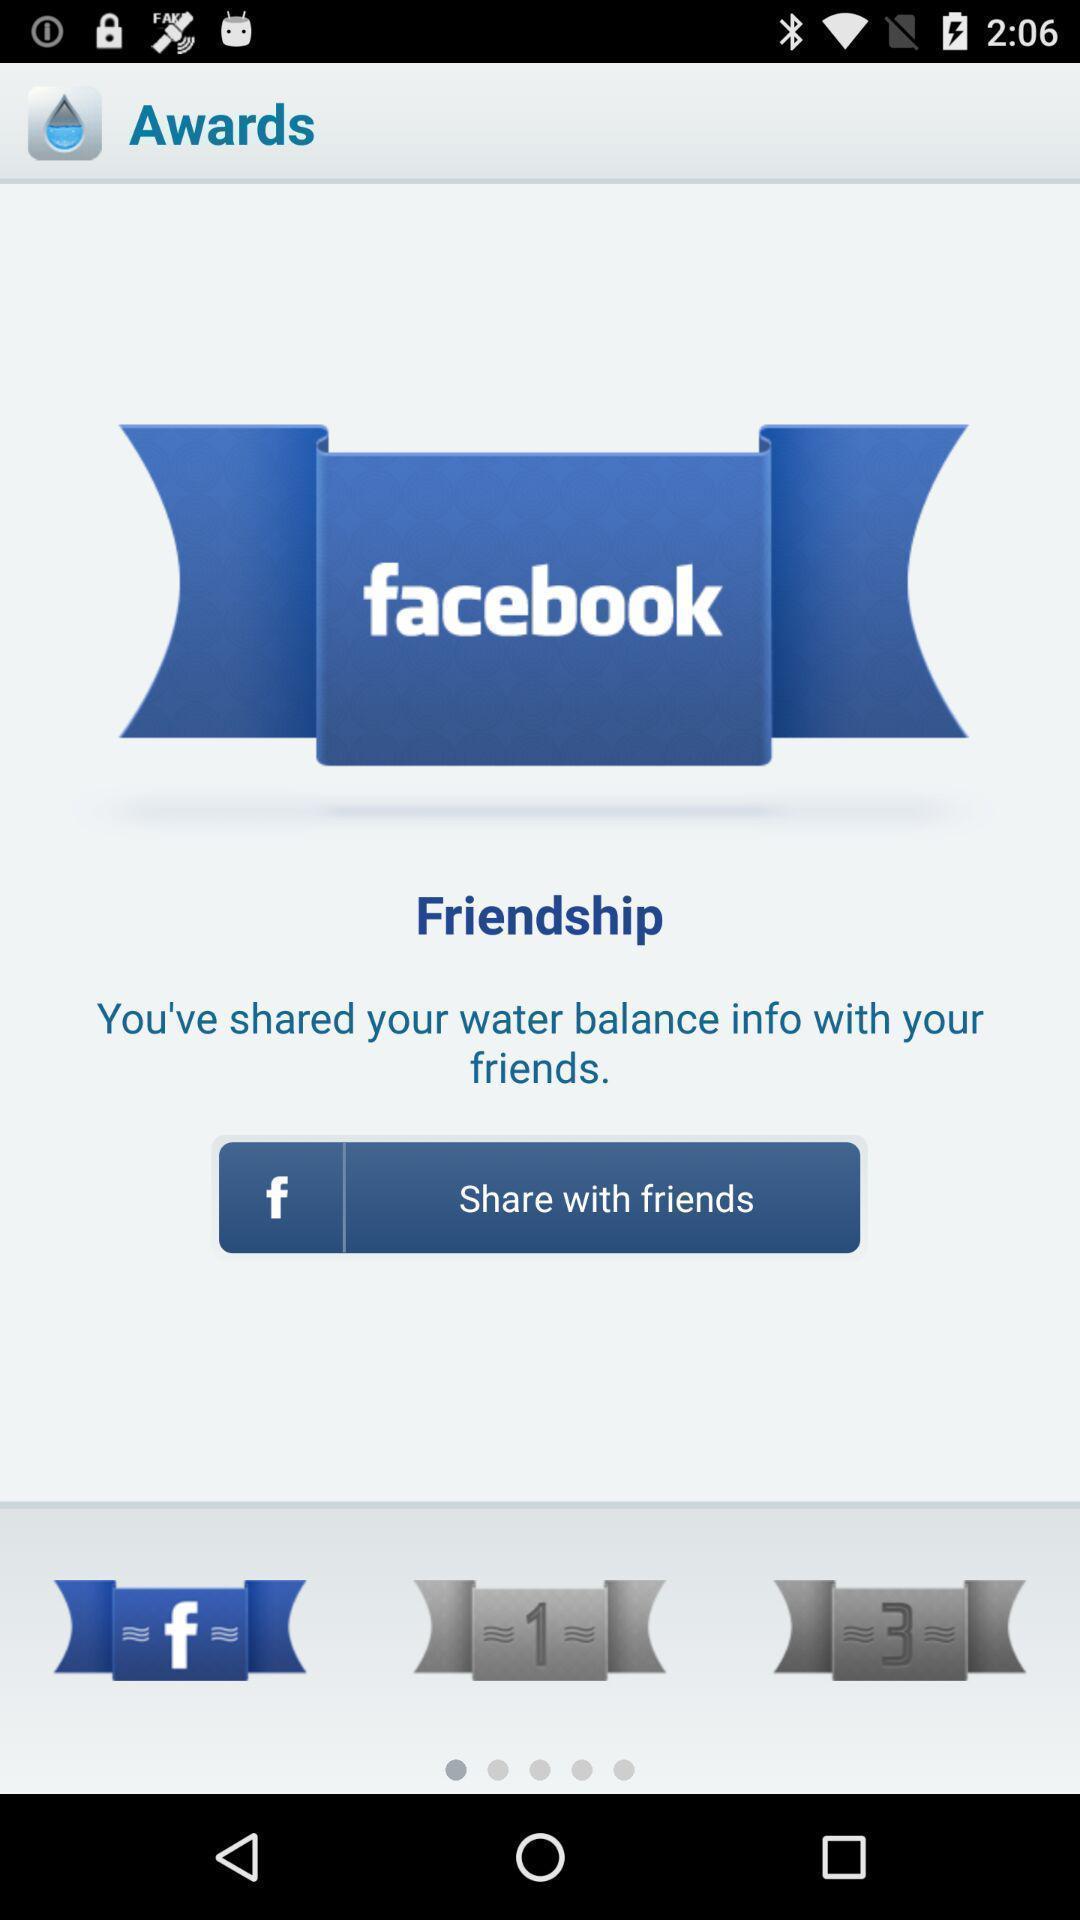Summarize the information in this screenshot. Screenshot of sharing water balance with friends. 